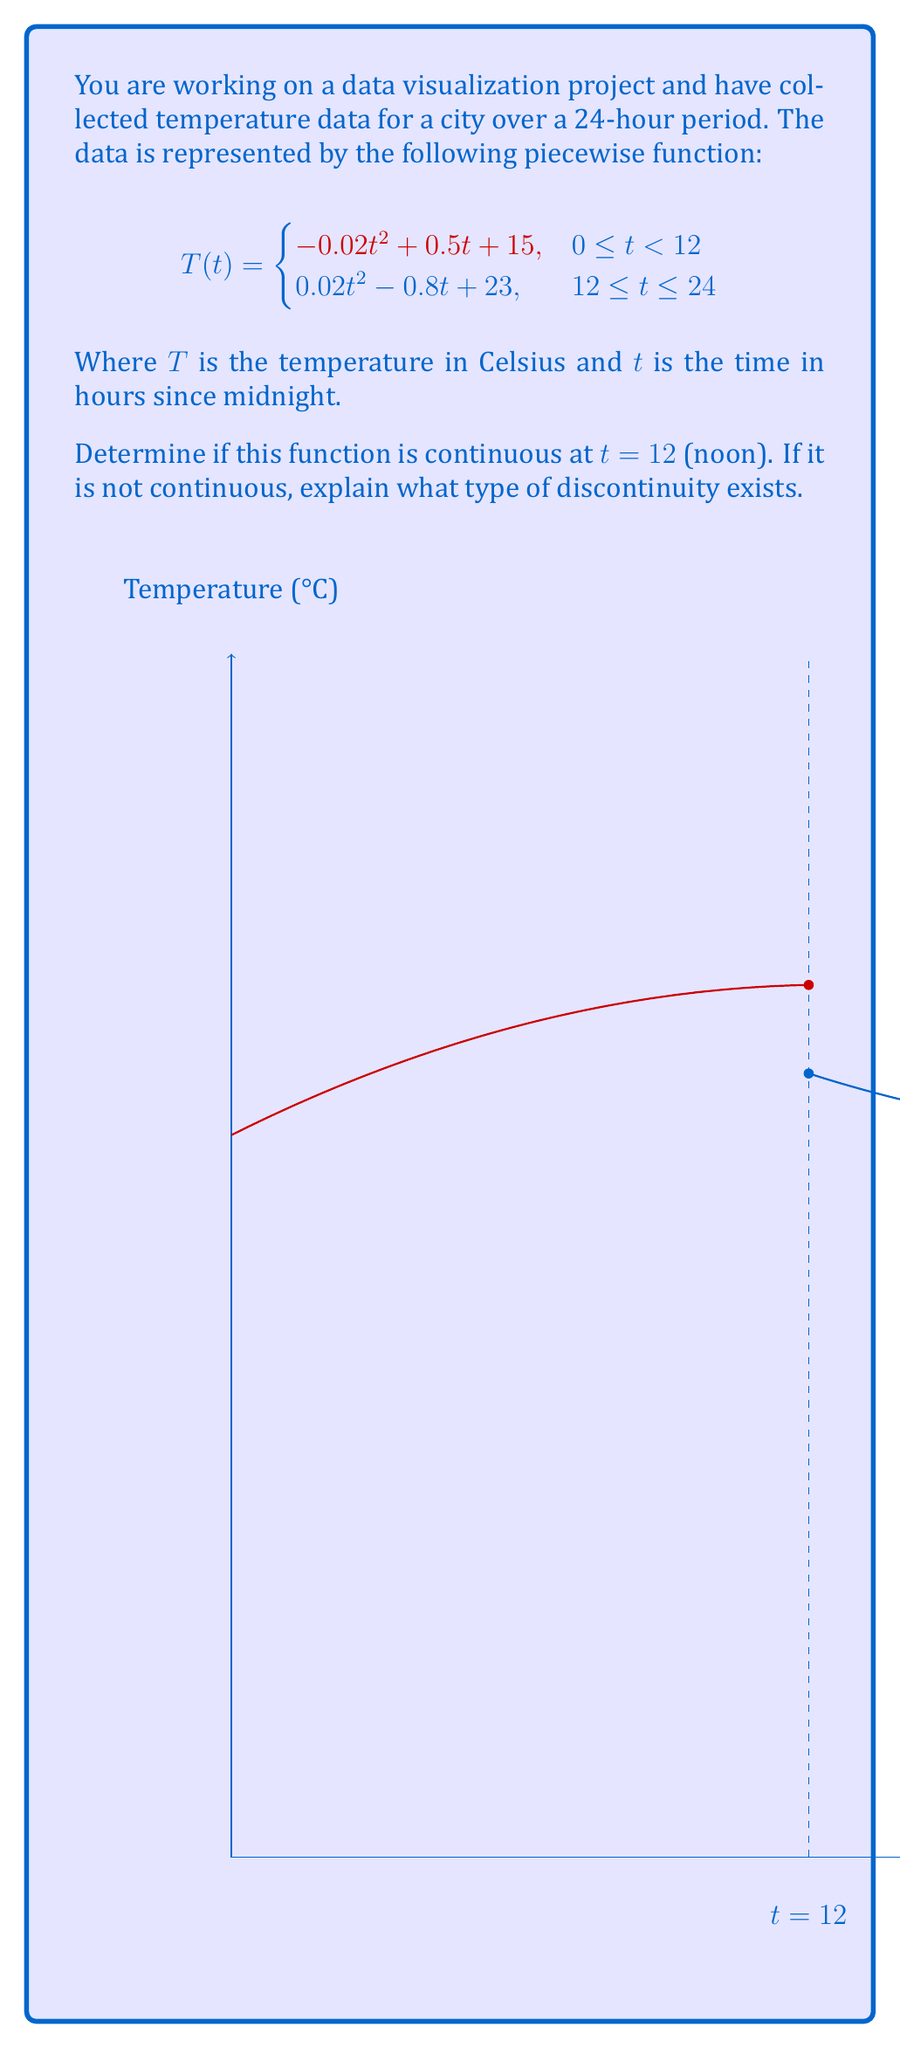Give your solution to this math problem. To determine if the function is continuous at $t = 12$, we need to check three conditions:

1. $T(12^-)$ exists (left-hand limit)
2. $T(12^+)$ exists (right-hand limit)
3. $T(12^-) = T(12^+) = T(12)$ (both limits equal the function value at $t = 12$)

Step 1: Calculate $T(12^-)$
$$\begin{aligned}
T(12^-) &= \lim_{t \to 12^-} (-0.02t^2 + 0.5t + 15) \\
&= -0.02(12)^2 + 0.5(12) + 15 \\
&= -2.88 + 6 + 15 \\
&= 18.12
\end{aligned}$$

Step 2: Calculate $T(12^+)$
$$\begin{aligned}
T(12^+) &= \lim_{t \to 12^+} (0.02t^2 - 0.8t + 23) \\
&= 0.02(12)^2 - 0.8(12) + 23 \\
&= 2.88 - 9.6 + 23 \\
&= 16.28
\end{aligned}$$

Step 3: Compare the limits
We can see that $T(12^-) \neq T(12^+)$, as $18.12 \neq 16.28$. This means the function is not continuous at $t = 12$.

The type of discontinuity at $t = 12$ is a jump discontinuity because the function has different finite limits from the left and right sides of $t = 12$.
Answer: Not continuous; jump discontinuity at $t = 12$ 